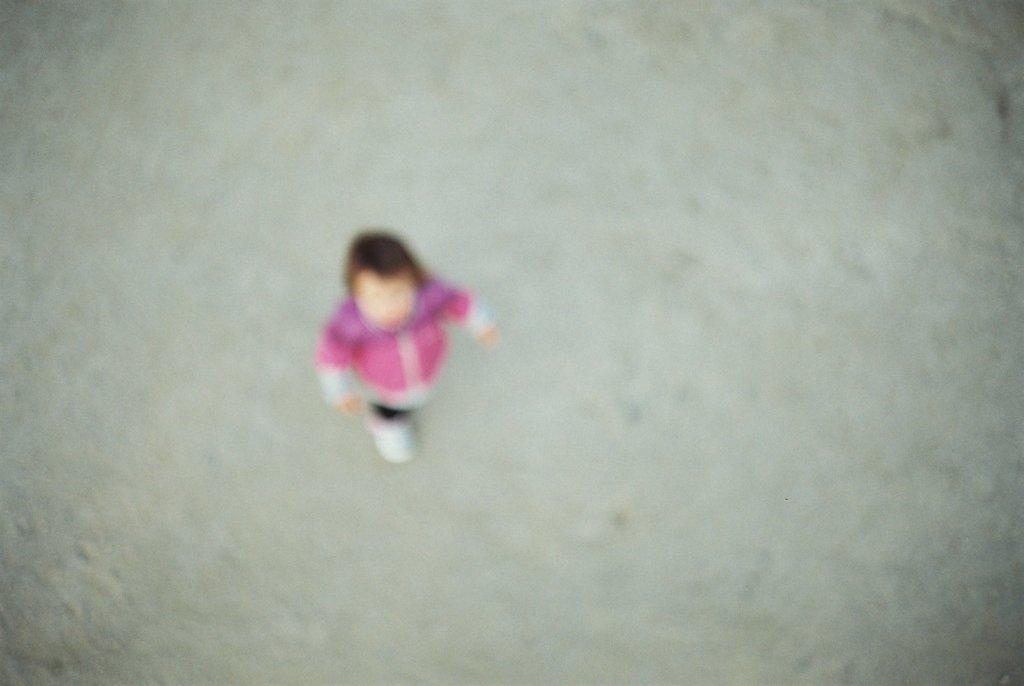What is the main subject of the picture? The main subject of the picture is a kid. What is the kid wearing in the image? The kid is wearing a pink dress. What is the kid's posture in the image? The kid is standing in the image. What direction is the kid looking in the image? The kid is looking upwards in the image. What type of cap is the mom wearing in the image? There is no mom present in the image, and therefore no cap to describe. 